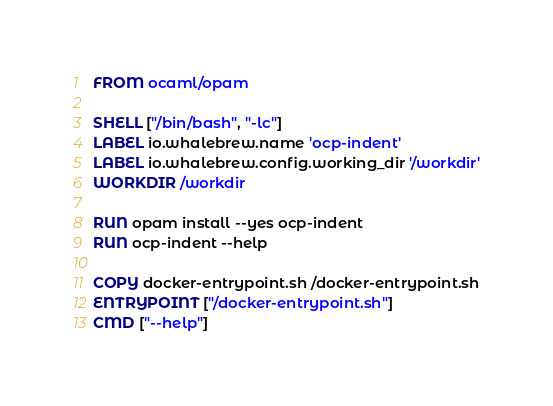Convert code to text. <code><loc_0><loc_0><loc_500><loc_500><_Dockerfile_>FROM ocaml/opam

SHELL ["/bin/bash", "-lc"]
LABEL io.whalebrew.name 'ocp-indent'
LABEL io.whalebrew.config.working_dir '/workdir'
WORKDIR /workdir

RUN opam install --yes ocp-indent
RUN ocp-indent --help

COPY docker-entrypoint.sh /docker-entrypoint.sh
ENTRYPOINT ["/docker-entrypoint.sh"]
CMD ["--help"]
</code> 